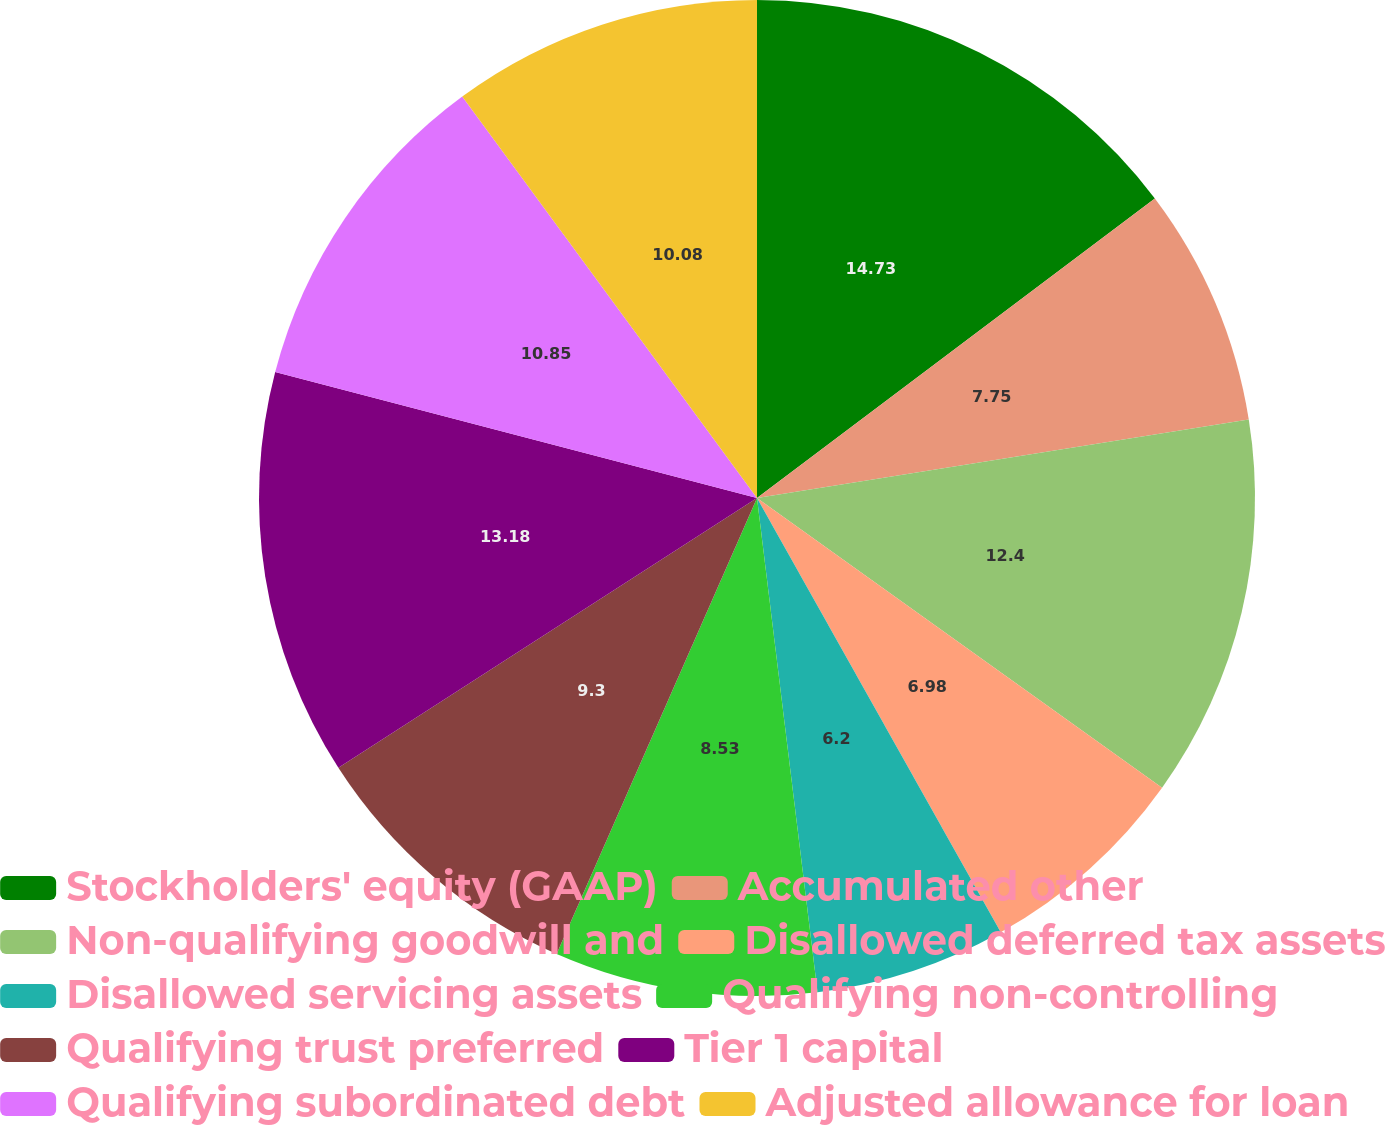<chart> <loc_0><loc_0><loc_500><loc_500><pie_chart><fcel>Stockholders' equity (GAAP)<fcel>Accumulated other<fcel>Non-qualifying goodwill and<fcel>Disallowed deferred tax assets<fcel>Disallowed servicing assets<fcel>Qualifying non-controlling<fcel>Qualifying trust preferred<fcel>Tier 1 capital<fcel>Qualifying subordinated debt<fcel>Adjusted allowance for loan<nl><fcel>14.73%<fcel>7.75%<fcel>12.4%<fcel>6.98%<fcel>6.2%<fcel>8.53%<fcel>9.3%<fcel>13.18%<fcel>10.85%<fcel>10.08%<nl></chart> 